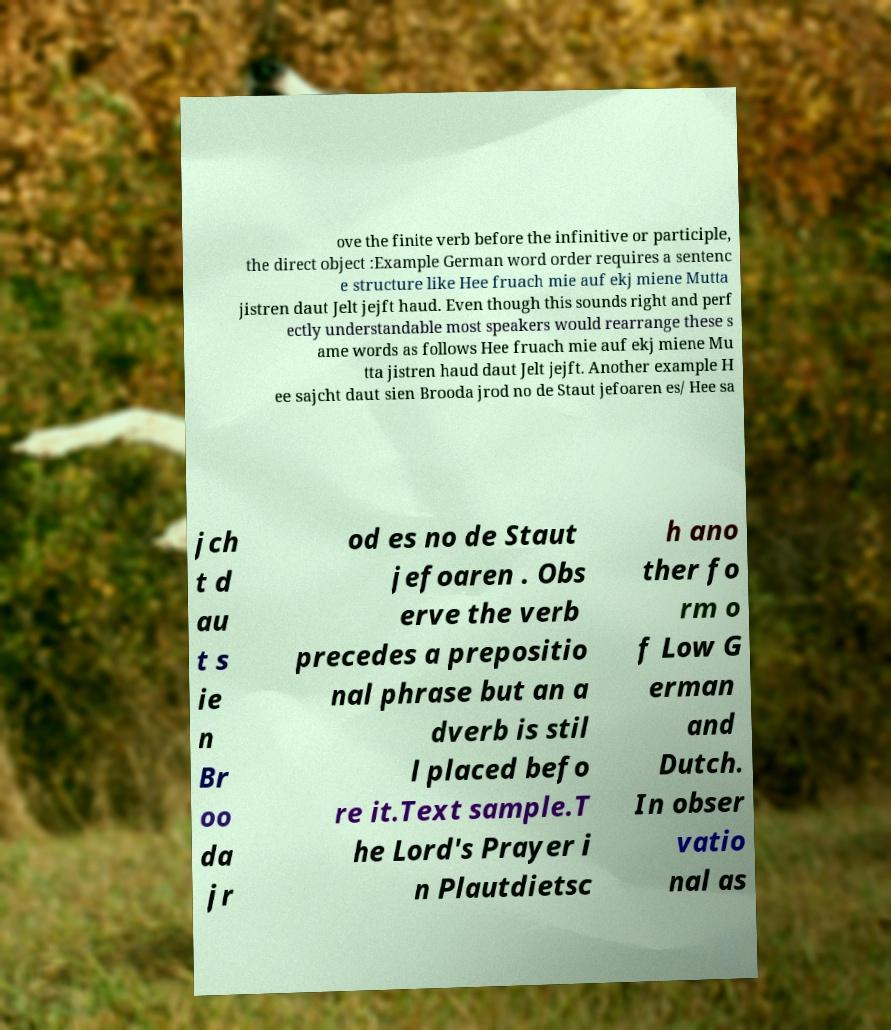For documentation purposes, I need the text within this image transcribed. Could you provide that? ove the finite verb before the infinitive or participle, the direct object :Example German word order requires a sentenc e structure like Hee fruach mie auf ekj miene Mutta jistren daut Jelt jejft haud. Even though this sounds right and perf ectly understandable most speakers would rearrange these s ame words as follows Hee fruach mie auf ekj miene Mu tta jistren haud daut Jelt jejft. Another example H ee sajcht daut sien Brooda jrod no de Staut jefoaren es/ Hee sa jch t d au t s ie n Br oo da jr od es no de Staut jefoaren . Obs erve the verb precedes a prepositio nal phrase but an a dverb is stil l placed befo re it.Text sample.T he Lord's Prayer i n Plautdietsc h ano ther fo rm o f Low G erman and Dutch. In obser vatio nal as 